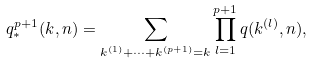<formula> <loc_0><loc_0><loc_500><loc_500>q _ { * } ^ { p + 1 } ( k , n ) = \sum _ { k ^ { ( 1 ) } + \cdots + k ^ { ( p + 1 ) } = k } \prod _ { l = 1 } ^ { p + 1 } q ( k ^ { ( l ) } , n ) ,</formula> 